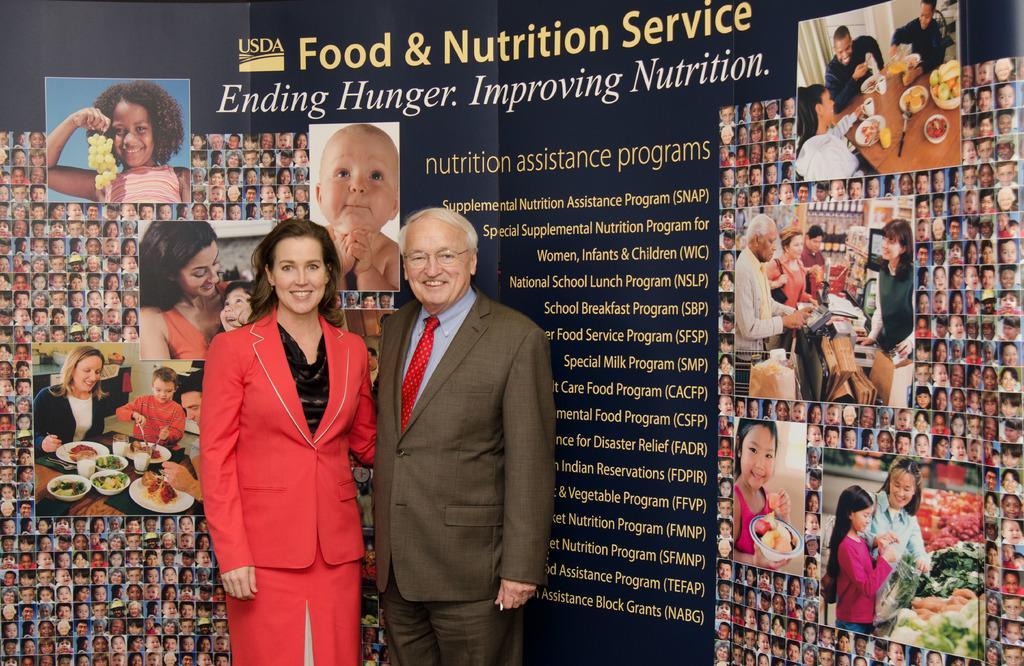Describe this image in one or two sentences. In this image in the front there are persons standing and smiling. In the background there is a board with some text and images on it. 